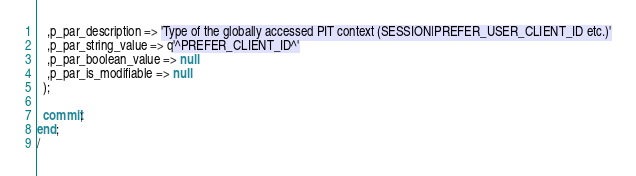<code> <loc_0><loc_0><loc_500><loc_500><_SQL_>   ,p_par_description => 'Type of the globally accessed PIT context (SESSION|PREFER_USER_CLIENT_ID etc.)'
   ,p_par_string_value => q'^PREFER_CLIENT_ID^'
   ,p_par_boolean_value => null
   ,p_par_is_modifiable => null
  );

  commit;
end;
/
</code> 